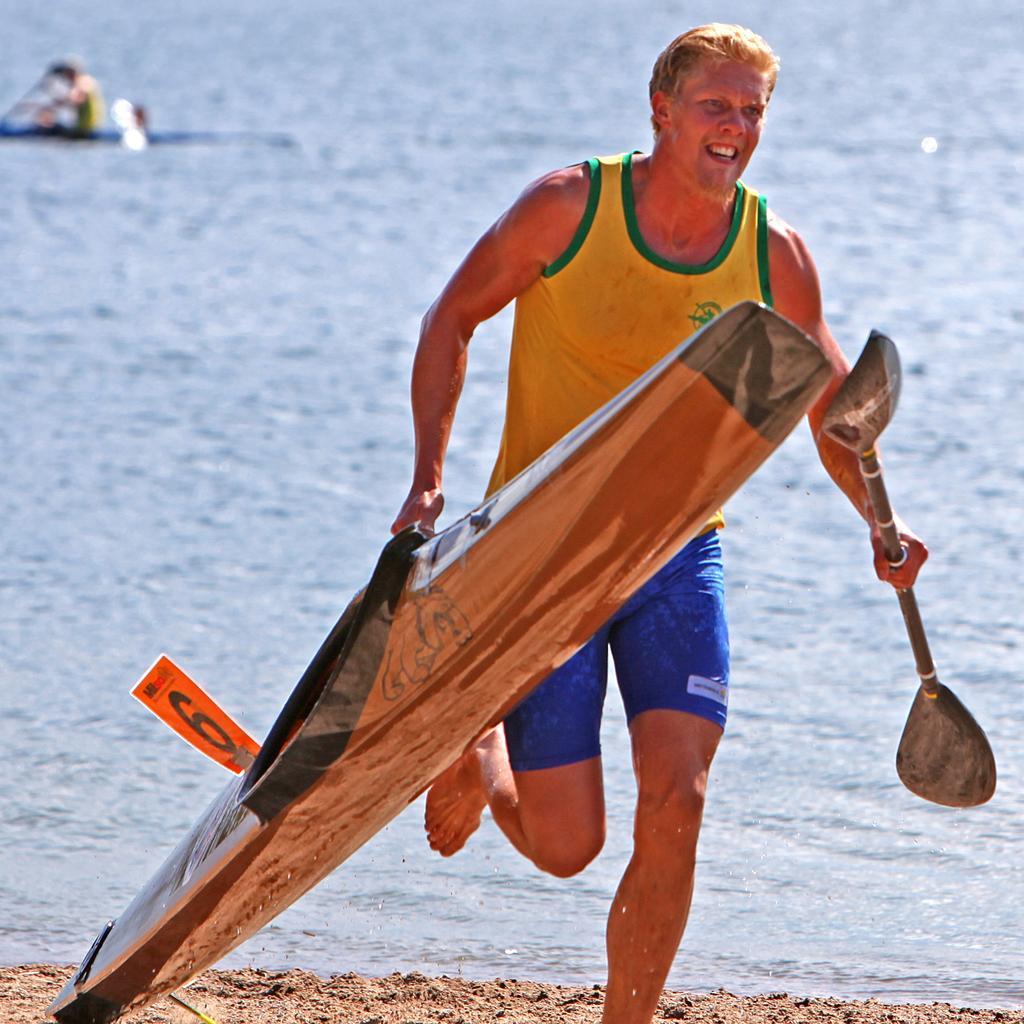Could you give a brief overview of what you see in this image? In the picture I can see a man and looks like he is running. He is holding a wooden surfboard in his right hand and there is an oar in his left hand. In the background, I can see the ocean and looks like there is a water vehicle on the top left side of the picture. 